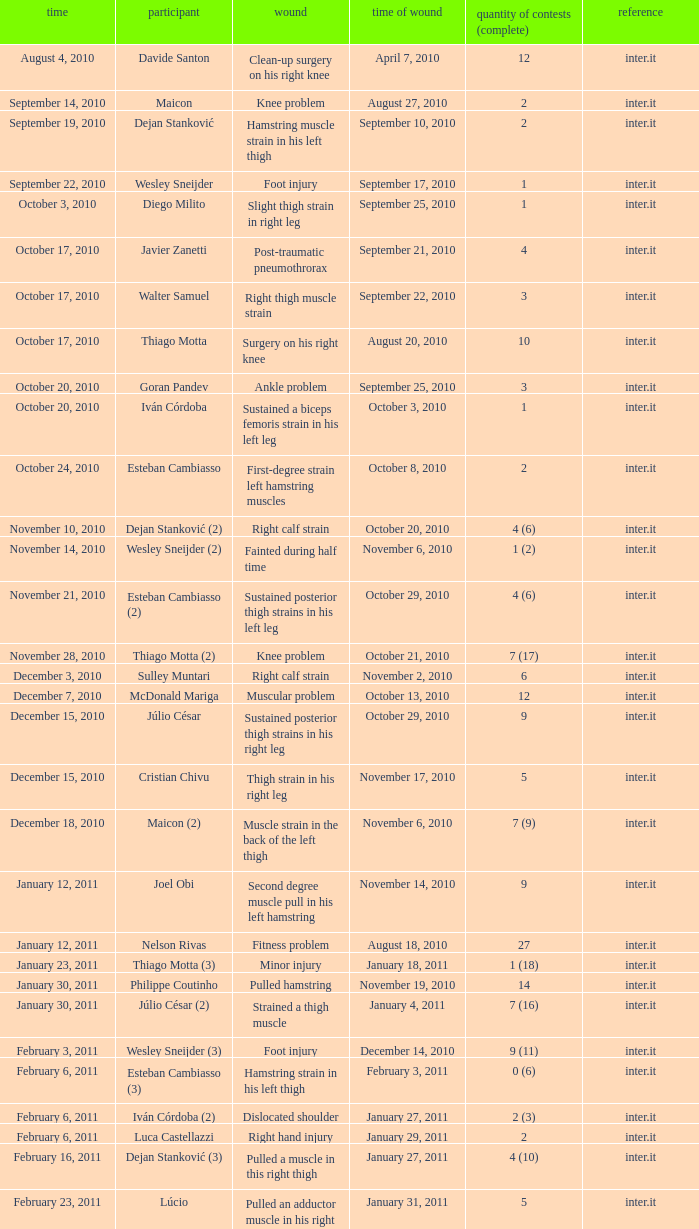What is the date of injury when the injury is foot injury and the number of matches (total) is 1? September 17, 2010. 